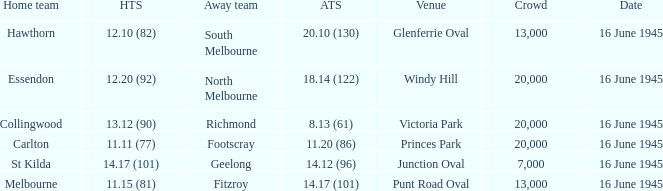Could you help me parse every detail presented in this table? {'header': ['Home team', 'HTS', 'Away team', 'ATS', 'Venue', 'Crowd', 'Date'], 'rows': [['Hawthorn', '12.10 (82)', 'South Melbourne', '20.10 (130)', 'Glenferrie Oval', '13,000', '16 June 1945'], ['Essendon', '12.20 (92)', 'North Melbourne', '18.14 (122)', 'Windy Hill', '20,000', '16 June 1945'], ['Collingwood', '13.12 (90)', 'Richmond', '8.13 (61)', 'Victoria Park', '20,000', '16 June 1945'], ['Carlton', '11.11 (77)', 'Footscray', '11.20 (86)', 'Princes Park', '20,000', '16 June 1945'], ['St Kilda', '14.17 (101)', 'Geelong', '14.12 (96)', 'Junction Oval', '7,000', '16 June 1945'], ['Melbourne', '11.15 (81)', 'Fitzroy', '14.17 (101)', 'Punt Road Oval', '13,000', '16 June 1945']]} What was the Home team score for the team that played South Melbourne? 12.10 (82). 